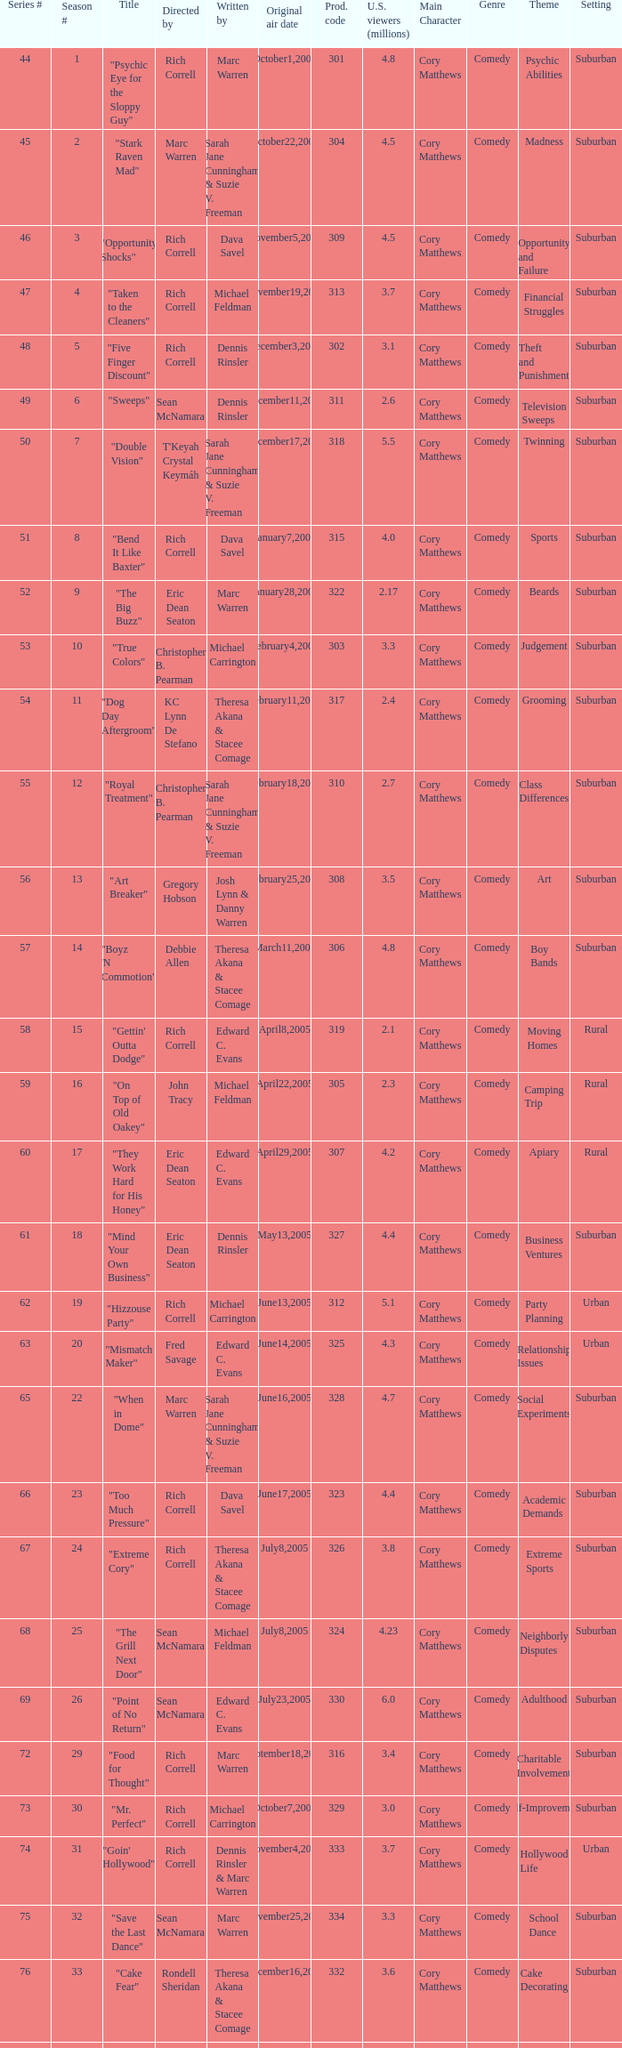In the season, which episode had a production code of 334? 32.0. 